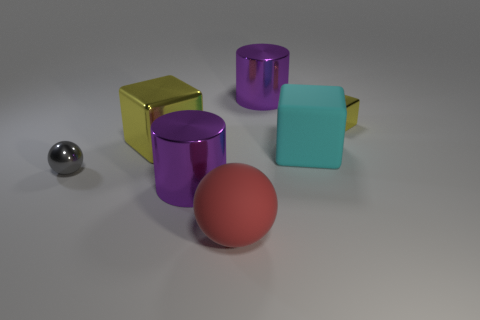What shapes and colors are present in the image? The image features a variety of geometric shapes, including a shiny silver sphere, a large shiny yellow cube, two shiny purple cylinders—one taller than the other—a matte red sphere, and a matte teal cube. Each object has its own distinct color and finish, adding to the visual diversity of the composition. 